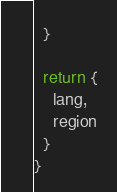Convert code to text. <code><loc_0><loc_0><loc_500><loc_500><_TypeScript_>  }

  return {
    lang,
    region
  }
}
</code> 